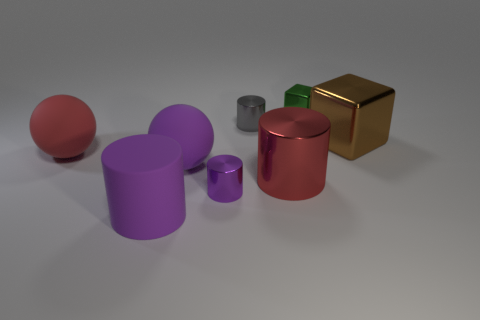Subtract all tiny purple cylinders. How many cylinders are left? 3 Subtract all purple spheres. How many spheres are left? 1 Add 1 large brown cubes. How many objects exist? 9 Subtract 1 cylinders. How many cylinders are left? 3 Add 8 big brown blocks. How many big brown blocks are left? 9 Add 3 large metal cylinders. How many large metal cylinders exist? 4 Subtract 0 gray balls. How many objects are left? 8 Subtract all blocks. How many objects are left? 6 Subtract all purple balls. Subtract all purple cubes. How many balls are left? 1 Subtract all purple cubes. How many gray cylinders are left? 1 